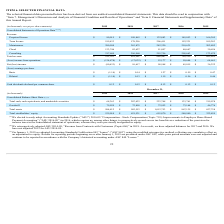From Pegasystems's financial document, What are the respective goodwill amounts in 2015 and 2016? The document shows two values: $46,776 and $73,164 (in thousands). From the document: "Goodwill $ 79,039 $ 72,858 $ 72,952 $ 73,164 $ 46,776 Goodwill $ 79,039 $ 72,858 $ 72,952 $ 73,164 $ 46,776..." Also, What are the respective goodwill amounts in 2016 and 2017? The document shows two values: $73,164 and $72,952 (in thousands). From the document: "Goodwill $ 79,039 $ 72,858 $ 72,952 $ 73,164 $ 46,776 Goodwill $ 79,039 $ 72,858 $ 72,952 $ 73,164 $ 46,776..." Also, What are the respective goodwill amounts in 2018 and 2019? The document shows two values: $72,858 and $79,039 (in thousands). From the document: "Goodwill $ 79,039 $ 72,858 $ 72,952 $ 73,164 $ 46,776 Goodwill $ 79,039 $ 72,858 $ 72,952 $ 73,164 $ 46,776..." Also, can you calculate: What is the average total cash, cash equivalents, and marketable securities in 2015 and 2016? To answer this question, I need to perform calculations using the financial data. The calculation is: ($219,078 + $133,761)/2 , which equals 176419.5 (in thousands). This is based on the information: "ketable securities $ 68,363 $ 207,423 $ 223,748 $ 133,761 $ 219,078 curities $ 68,363 $ 207,423 $ 223,748 $ 133,761 $ 219,078..." The key data points involved are: 133,761, 219,078. Also, can you calculate: What is the percentage change in the company's goodwill between 2017 and 2018? To answer this question, I need to perform calculations using the financial data. The calculation is: (72,858 - 72,952)/72,952 , which equals -0.13 (percentage). This is based on the information: "Goodwill $ 79,039 $ 72,858 $ 72,952 $ 73,164 $ 46,776 Goodwill $ 79,039 $ 72,858 $ 72,952 $ 73,164 $ 46,776..." The key data points involved are: 72,858, 72,952. Also, can you calculate: What is the percentage change in the company's goodwill between 2018 and 2019? To answer this question, I need to perform calculations using the financial data. The calculation is: (79,039 - 72,858)/72,858 , which equals 8.48 (percentage). This is based on the information: "Goodwill $ 79,039 $ 72,858 $ 72,952 $ 73,164 $ 46,776 Goodwill $ 79,039 $ 72,858 $ 72,952 $ 73,164 $ 46,776..." The key data points involved are: 72,858, 79,039. 